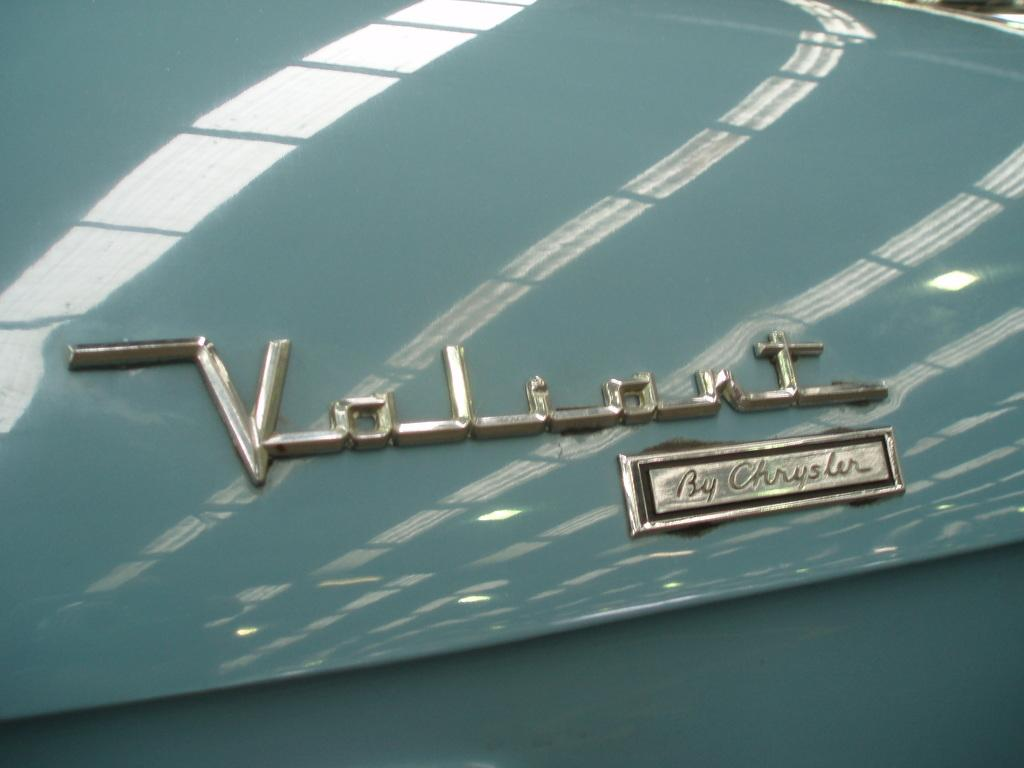What type of material is the object in the image made of? The object in the image is made of metal. What is written or depicted on the metal object? There is text on the metal object. Can you describe any additional visual elements on the metal object? There is a reflection visible on the metal object. What type of crayon is being used to draw on the metal object in the image? There is no crayon or drawing activity present in the image; it features a metal object with text and a reflection. 